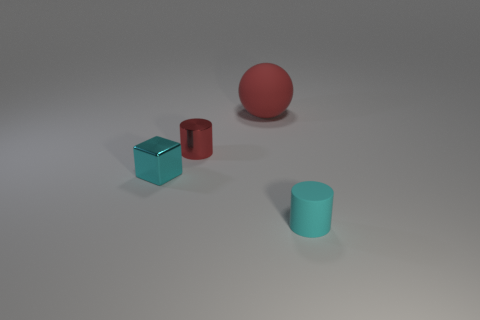There is a thing that is behind the small shiny block and right of the small red metal cylinder; what is its shape?
Offer a terse response. Sphere. Is the number of tiny metallic things that are right of the cyan rubber cylinder less than the number of blocks that are behind the cyan block?
Ensure brevity in your answer.  No. There is a object that is both in front of the metallic cylinder and behind the small cyan rubber thing; what size is it?
Ensure brevity in your answer.  Small. Are there any matte cylinders right of the cylinder that is behind the small thing that is in front of the small metallic cube?
Your answer should be very brief. Yes. Is there a tiny cyan shiny cube?
Your answer should be very brief. Yes. Is the number of metal cylinders that are left of the small cyan block greater than the number of things right of the red sphere?
Provide a succinct answer. No. What size is the cylinder that is the same material as the small cyan cube?
Provide a short and direct response. Small. What size is the cylinder that is behind the matte object in front of the red thing that is to the left of the rubber ball?
Ensure brevity in your answer.  Small. There is a object on the left side of the tiny red metallic cylinder; what color is it?
Make the answer very short. Cyan. Are there more tiny red metallic cylinders that are behind the cyan matte cylinder than big purple objects?
Ensure brevity in your answer.  Yes. 